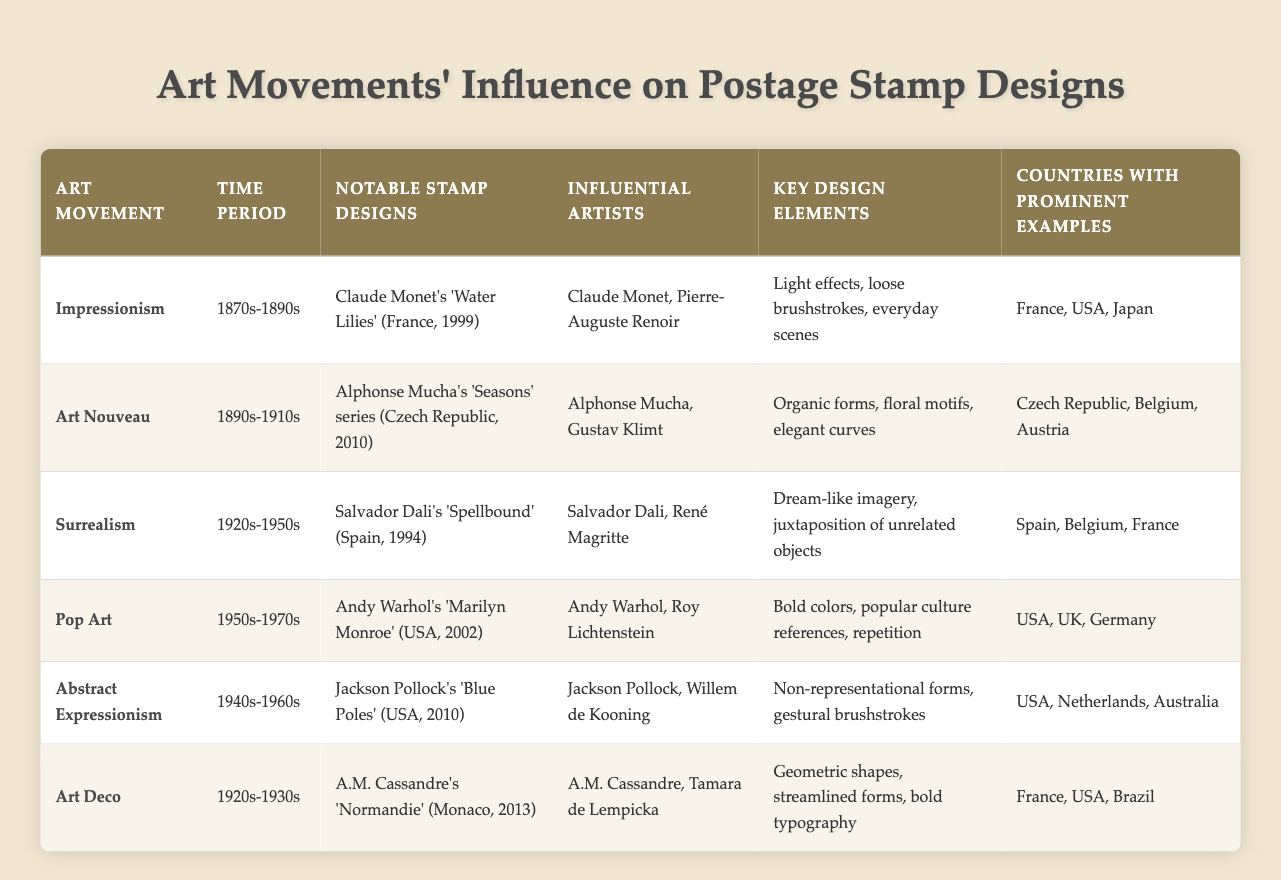What is the time period of the Art Nouveau movement? The table lists the Art Nouveau movement under the "Time Period" column with the value "1890s-1910s."
Answer: 1890s-1910s Which art movement is associated with Claude Monet? The table shows that Claude Monet is listed under the "Influential Artists" for the Impressionism movement, indicating his association.
Answer: Impressionism Which art movement has notable stamp designs featuring 'Blue Poles'? By checking the "Notable Stamp Designs" column, we see that 'Blue Poles' is mentioned under "Abstract Expressionism."
Answer: Abstract Expressionism Which artistic movement was influential during the 1920s-1950s? The table indicates that both Surrealism and Art Deco were influential during that timeframe; however, Surrealism specifically has notable examples listed, making it prominent in that period.
Answer: Surrealism Did the Pop Art movement feature bold colors in its design elements? The table confirms that the key design elements of Pop Art include "Bold colors," thus the statement is true.
Answer: Yes What are the key design elements of Art Nouveau? The table lists "Organic forms, floral motifs, elegant curves" under the key design elements for the Art Nouveau movement.
Answer: Organic forms, floral motifs, elegant curves In how many countries are Impressionism and Pop Art both represented with prominent examples? The countries associated with Impressionism are France, USA, and Japan, while for Pop Art, they are USA, UK, and Germany. The only country in common is the USA, indicating one shared country.
Answer: 1 What are the notable designs from the Abstract Expressionism movement? Referencing the "Notable Stamp Designs" column, we find that "Jackson Pollock's 'Blue Poles' (USA, 2010)" is the relevant example for Abstract Expressionism.
Answer: Jackson Pollock's 'Blue Poles' Which movement had a prominent artist named A.M. Cassandre? By looking at the "Influential Artists" column, we see A.M. Cassandre listed under the Art Deco movement, indicating his prominence there.
Answer: Art Deco 